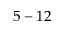<formula> <loc_0><loc_0><loc_500><loc_500>5 - 1 2</formula> 